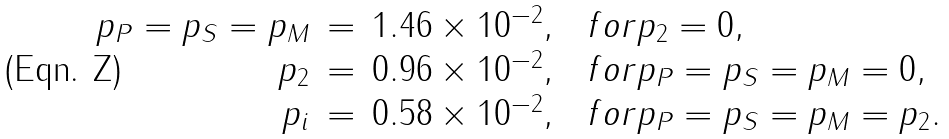Convert formula to latex. <formula><loc_0><loc_0><loc_500><loc_500>\begin{array} { r c l c l } p _ { P } = p _ { S } = p _ { M } & = & 1 . 4 6 \times 1 0 ^ { - 2 } , & & f o r p _ { 2 } = 0 , \\ p _ { 2 } & = & 0 . 9 6 \times 1 0 ^ { - 2 } , & & f o r p _ { P } = p _ { S } = p _ { M } = 0 , \\ p _ { i } & = & 0 . 5 8 \times 1 0 ^ { - 2 } , & & f o r p _ { P } = p _ { S } = p _ { M } = p _ { 2 } . \end{array}</formula> 